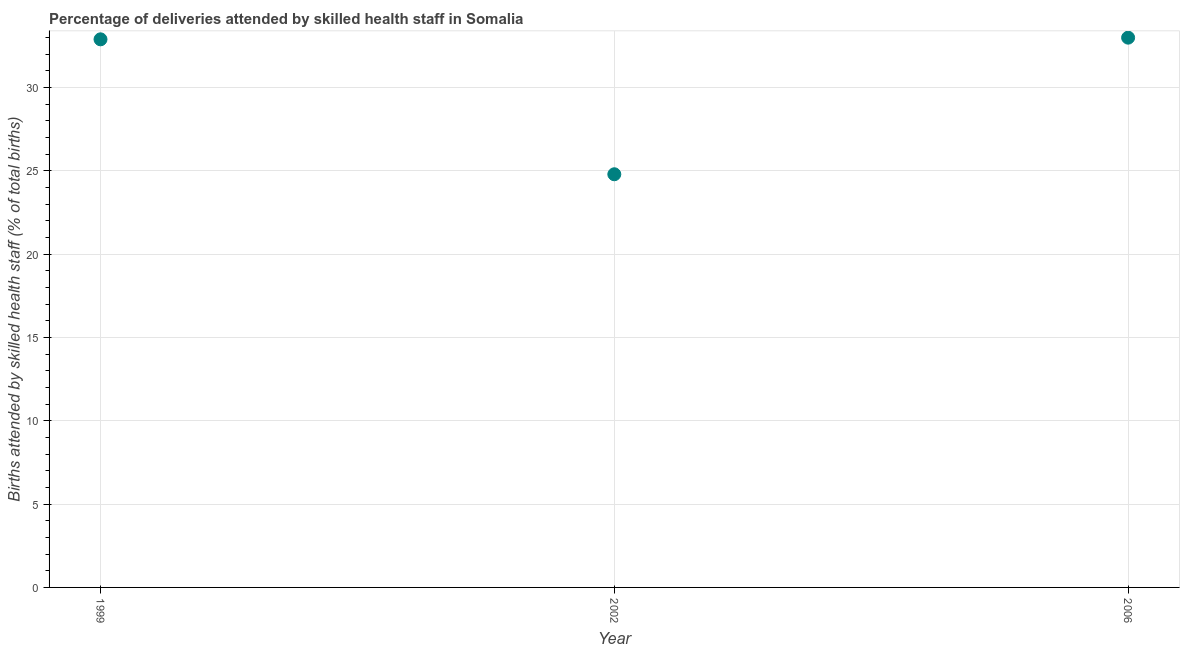What is the number of births attended by skilled health staff in 1999?
Your answer should be very brief. 32.9. Across all years, what is the minimum number of births attended by skilled health staff?
Your answer should be compact. 24.8. In which year was the number of births attended by skilled health staff maximum?
Keep it short and to the point. 2006. What is the sum of the number of births attended by skilled health staff?
Your answer should be compact. 90.7. What is the difference between the number of births attended by skilled health staff in 1999 and 2006?
Keep it short and to the point. -0.1. What is the average number of births attended by skilled health staff per year?
Ensure brevity in your answer.  30.23. What is the median number of births attended by skilled health staff?
Ensure brevity in your answer.  32.9. What is the ratio of the number of births attended by skilled health staff in 2002 to that in 2006?
Give a very brief answer. 0.75. Is the difference between the number of births attended by skilled health staff in 1999 and 2006 greater than the difference between any two years?
Give a very brief answer. No. What is the difference between the highest and the second highest number of births attended by skilled health staff?
Make the answer very short. 0.1. How many years are there in the graph?
Your response must be concise. 3. Are the values on the major ticks of Y-axis written in scientific E-notation?
Provide a succinct answer. No. Does the graph contain any zero values?
Offer a terse response. No. What is the title of the graph?
Provide a succinct answer. Percentage of deliveries attended by skilled health staff in Somalia. What is the label or title of the Y-axis?
Make the answer very short. Births attended by skilled health staff (% of total births). What is the Births attended by skilled health staff (% of total births) in 1999?
Offer a very short reply. 32.9. What is the Births attended by skilled health staff (% of total births) in 2002?
Your response must be concise. 24.8. What is the difference between the Births attended by skilled health staff (% of total births) in 1999 and 2002?
Provide a short and direct response. 8.1. What is the difference between the Births attended by skilled health staff (% of total births) in 2002 and 2006?
Your answer should be very brief. -8.2. What is the ratio of the Births attended by skilled health staff (% of total births) in 1999 to that in 2002?
Provide a succinct answer. 1.33. What is the ratio of the Births attended by skilled health staff (% of total births) in 2002 to that in 2006?
Offer a very short reply. 0.75. 